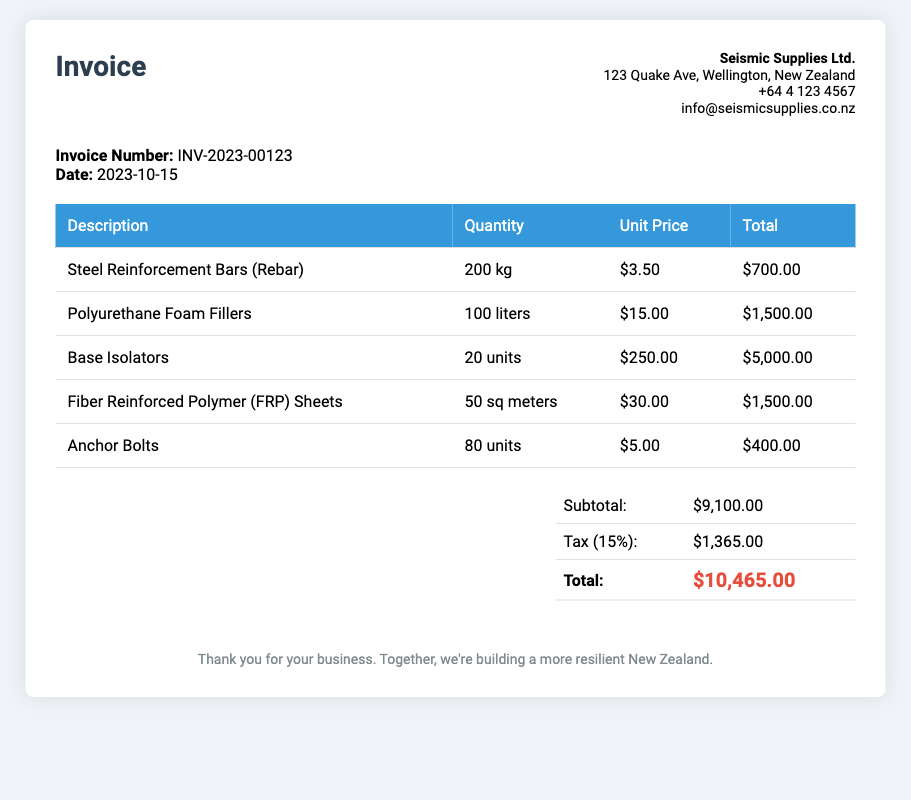What is the invoice number? The invoice number is specified in the document under the invoice information section.
Answer: INV-2023-00123 What is the date of the invoice? The date is provided in the invoice information section, detailing when the invoice was issued.
Answer: 2023-10-15 Who is the supplier? The supplier's name and address can be found at the top of the invoice.
Answer: Seismic Supplies Ltd What is the quantity of Polyurethane Foam Fillers purchased? The quantity is listed in the table under the corresponding item description.
Answer: 100 liters What is the unit price of Base Isolators? The unit price is found in the table under the specific item information.
Answer: $250.00 What is the subtotal amount? The subtotal is calculated as the sum of all item totals before tax.
Answer: $9,100.00 What is the total amount after tax? The total is displayed as the final amount payable, including tax.
Answer: $10,465.00 How much is the tax applied to the invoice? The tax amount is clearly stated in the total section of the document.
Answer: $1,365.00 How many units of Anchor Bolts were ordered? The quantity of Anchor Bolts is detailed in the invoice table.
Answer: 80 units 